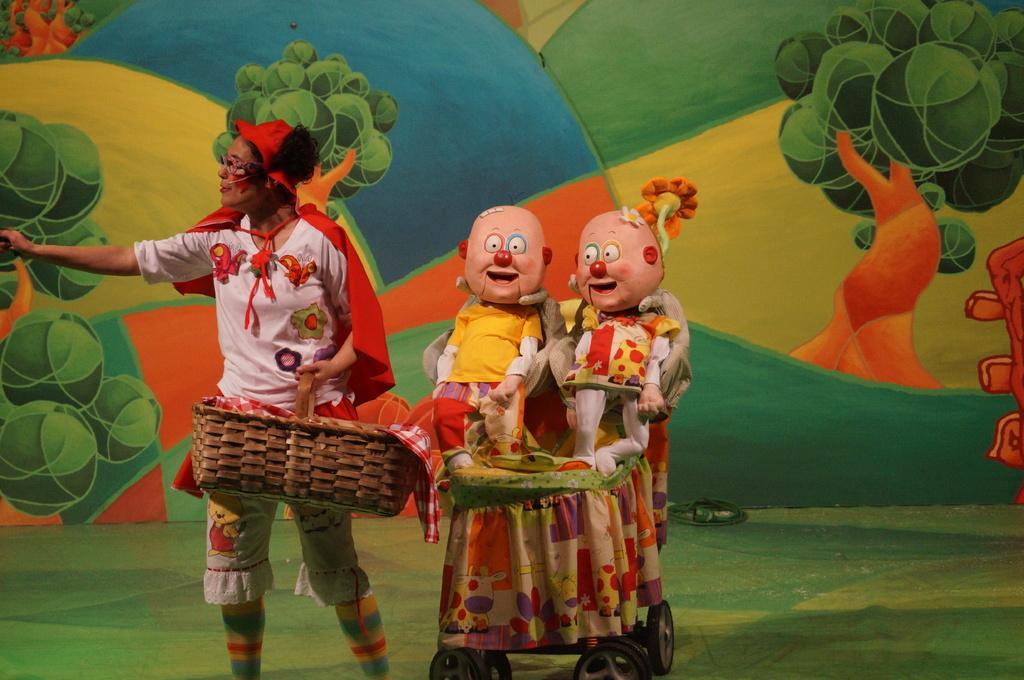Can you describe this image briefly? In this image we can see a person wearing specs and cap. And the person is holding a basket. Inside the basket there is a cloth. Near to the person there are toys on something with wheels. In the background there is a wall with paintings. 